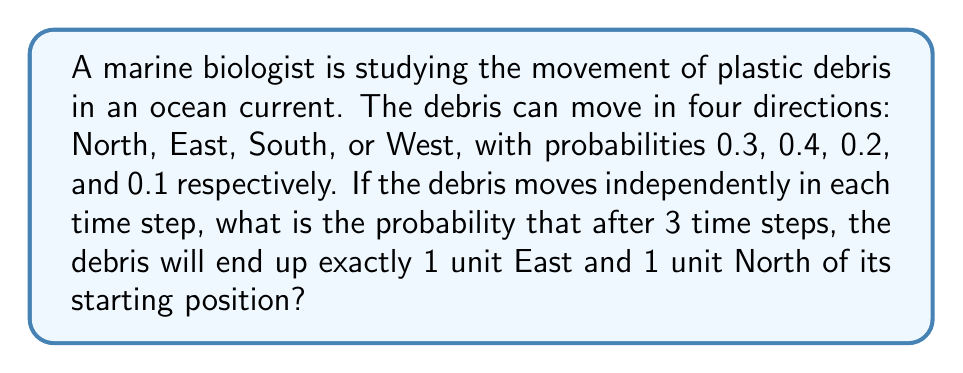Show me your answer to this math problem. To solve this problem, we need to use the concept of stochastic processes and probability theory. Let's break it down step by step:

1) First, we need to identify all possible paths that lead to the desired end position (1 East, 1 North). There are six possible paths:
   - North, North, East
   - North, East, North
   - East, North, North
   - North, East, East
   - East, North, East
   - East, East, North

2) Now, we need to calculate the probability of each path:

   For North, North, East:
   $P(\text{NNE}) = 0.3 \times 0.3 \times 0.4 = 0.036$

   For North, East, North:
   $P(\text{NEN}) = 0.3 \times 0.4 \times 0.3 = 0.036$

   For East, North, North:
   $P(\text{ENN}) = 0.4 \times 0.3 \times 0.3 = 0.036$

   For North, East, East:
   $P(\text{NEE}) = 0.3 \times 0.4 \times 0.4 = 0.048$

   For East, North, East:
   $P(\text{ENE}) = 0.4 \times 0.3 \times 0.4 = 0.048$

   For East, East, North:
   $P(\text{EEN}) = 0.4 \times 0.4 \times 0.3 = 0.048$

3) The total probability is the sum of the probabilities of all possible paths:

   $$P(\text{total}) = 0.036 + 0.036 + 0.036 + 0.048 + 0.048 + 0.048 = 0.252$$

Therefore, the probability that the debris will end up exactly 1 unit East and 1 unit North of its starting position after 3 time steps is 0.252 or 25.2%.
Answer: 0.252 or 25.2% 